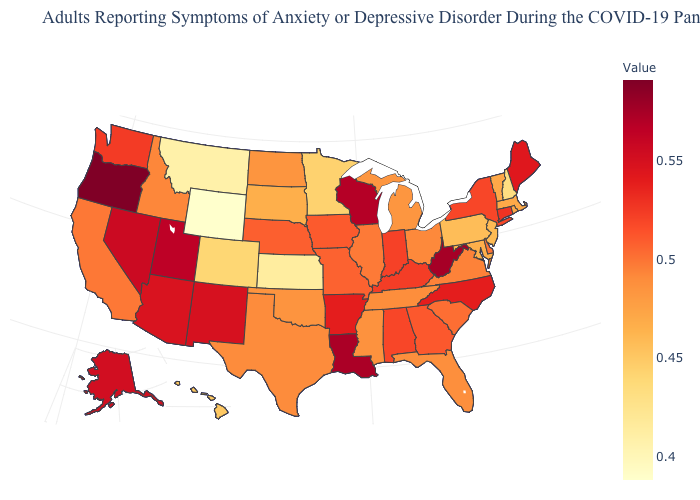Does Iowa have a higher value than Michigan?
Quick response, please. Yes. Does the map have missing data?
Keep it brief. No. Among the states that border Illinois , which have the lowest value?
Keep it brief. Missouri. Does California have the lowest value in the USA?
Answer briefly. No. Which states hav the highest value in the South?
Be succinct. West Virginia. 